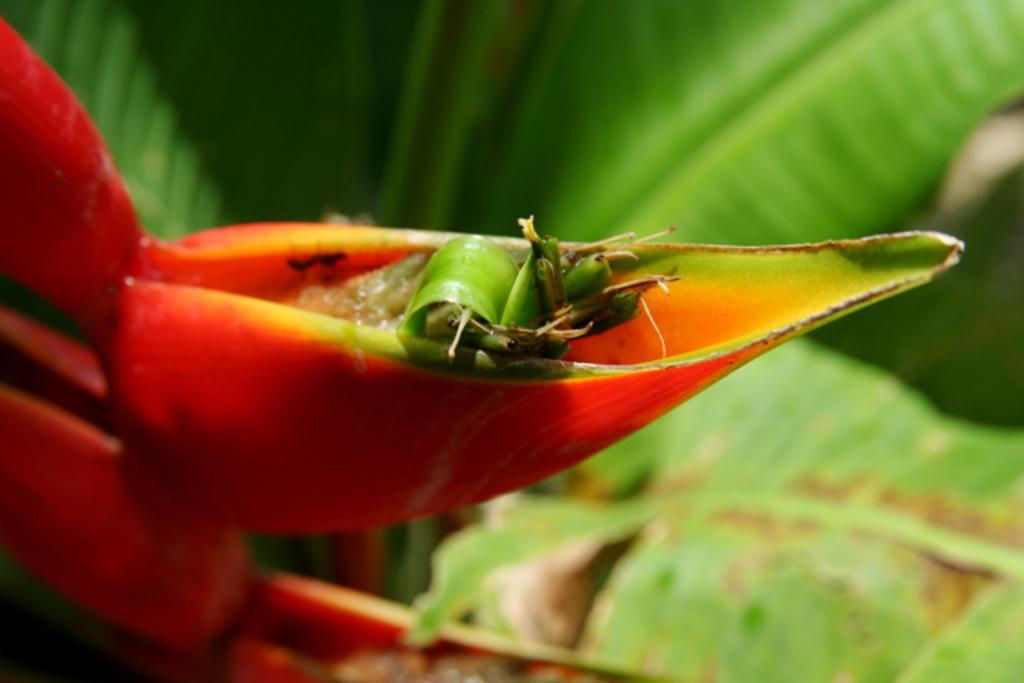What is the color of the bud on the left side of the image? The bud is in orange color on the left side of the image. What type of vegetation is present in the middle of the image? There are green leaves in the middle of the image. What is the reaction of the account to the taste of the orange bud in the image? There is no account or taste mentioned in the image, as it only features a bud and green leaves. 